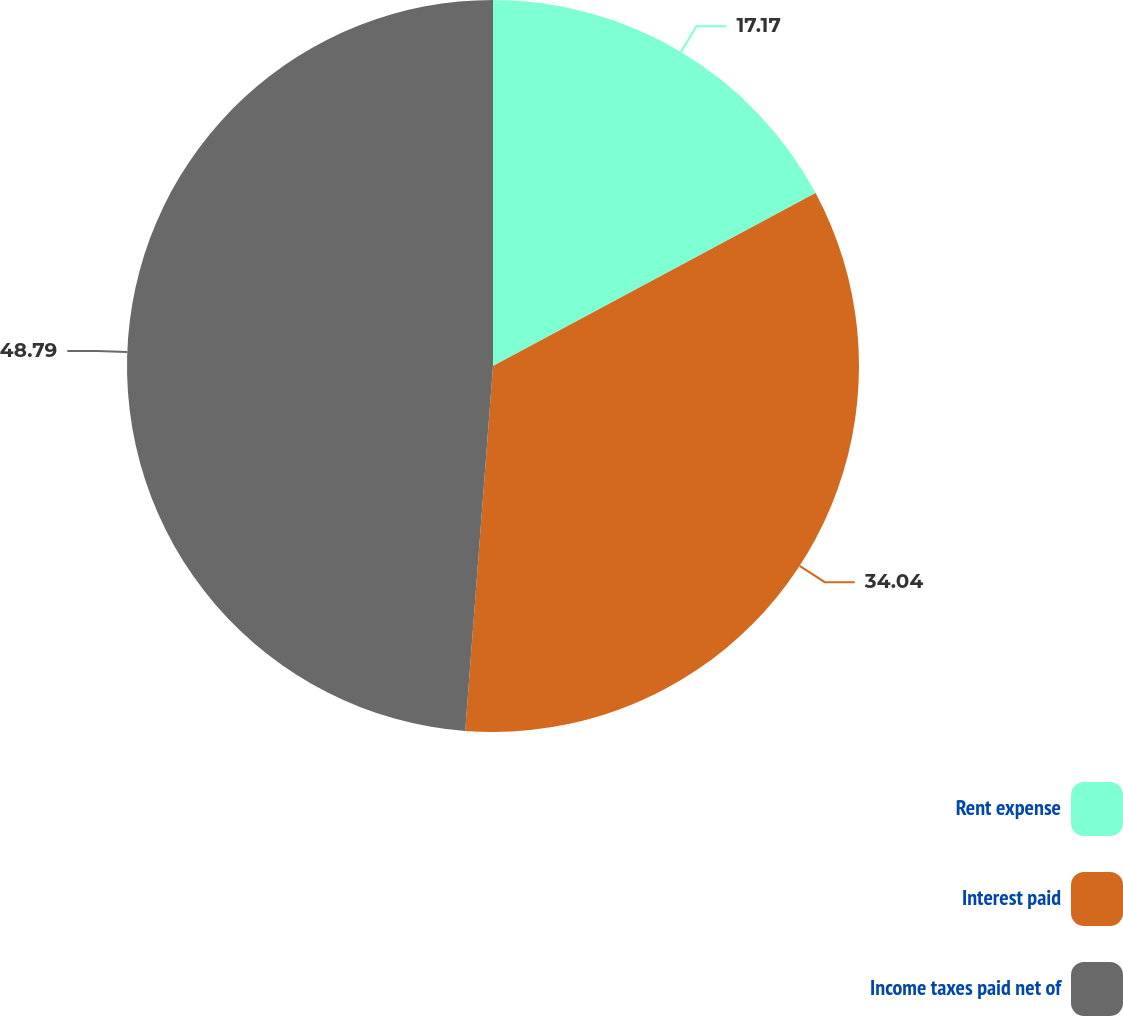Convert chart to OTSL. <chart><loc_0><loc_0><loc_500><loc_500><pie_chart><fcel>Rent expense<fcel>Interest paid<fcel>Income taxes paid net of<nl><fcel>17.17%<fcel>34.04%<fcel>48.79%<nl></chart> 